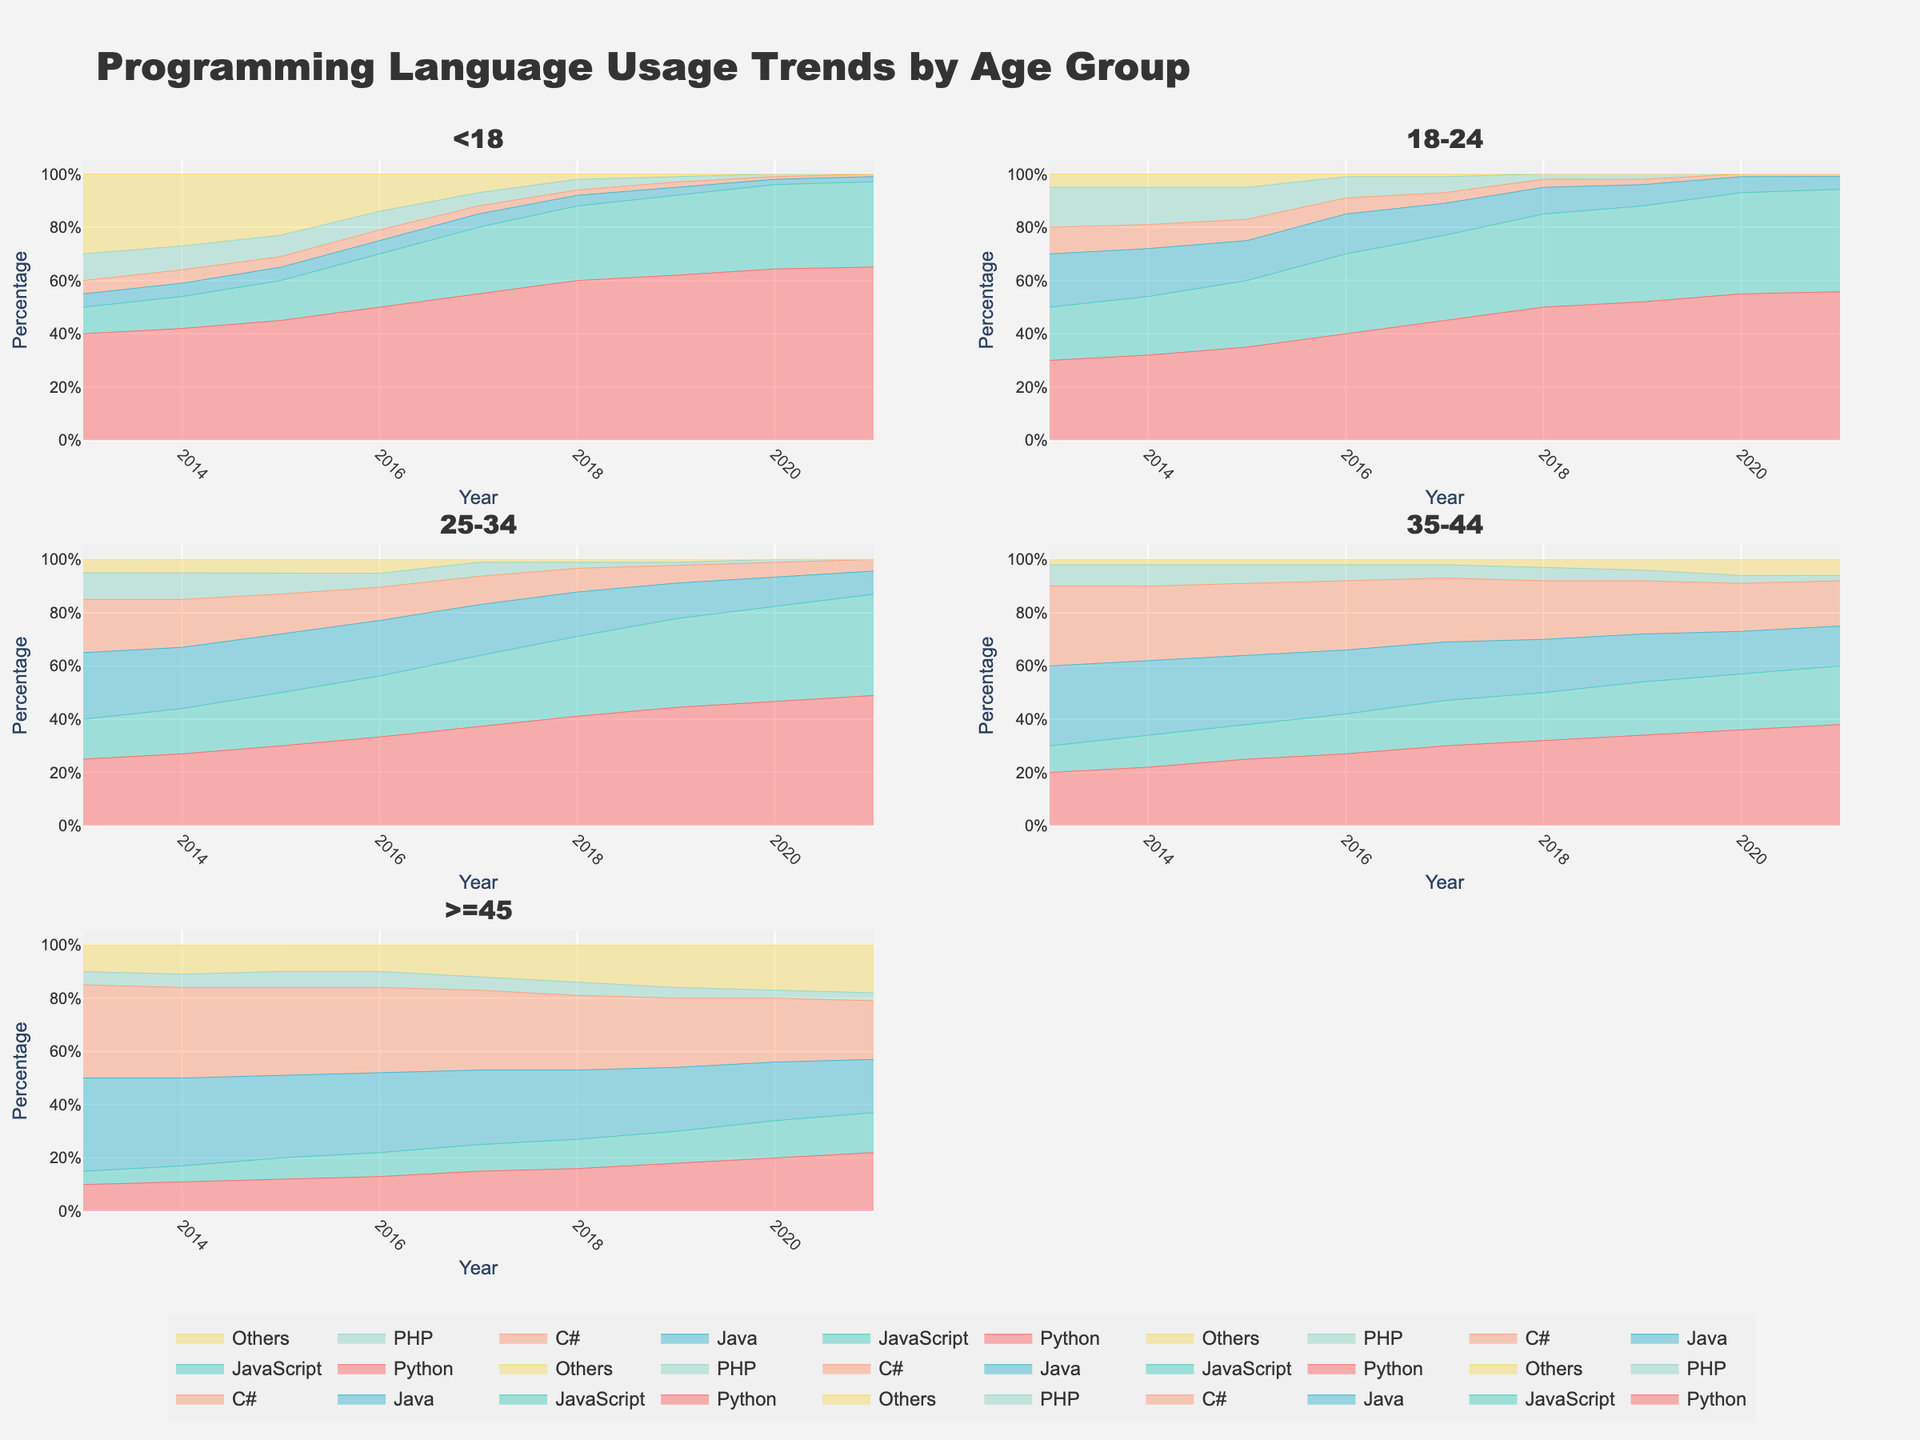What is the title of the figure? The title of the figure is displayed prominently at the top. It helps to understand the main subject of the figure.
Answer: Programming Language Usage Trends by Age Group Which programming language has the highest percentage usage in the age group "<18" in 2016? To find the highest percentage usage in 2016 for the "<18" age group, locate the subplot for "<18". Then, identify the stack area that reaches the highest point in that year. Python is the tallest stack in 2016.
Answer: Python How has the usage trend of JavaScript changed for the "25-34" age group from 2013 to 2021? For this, look at the JavaScript area in the subplot for "25-34". Track the change from the left side (2013) to the right side (2021). JavaScript usage increases consistently over the years.
Answer: Increased Which age group shows the most significant increase in Python usage between 2013 and 2021? By comparing the increase in Python usage across all age groups from 2013 to 2021, we can see which group has the most significant change. In every subplot, observe the growth in the Python area. The "<18" age group shows the most significant increase.
Answer: <18 In 2019, what is the combined usage percentage of C# and PHP for the "35-44" age group? In the "35-44" age group's subplot, find the values for C# and PHP in 2019. Add these percentages together to get the combined usage. C# is 20%, and PHP is 4%. Summing them gives 24%.
Answer: 24% Which programming language's usage declined the most for those aged ">=45" between 2013 and 2021? Examine the ">=45" age group subplot, observing the trends for all languages between 2013 and 2021. Identify the language with the most noticeable decrease. Java's percentage drops significantly over this period.
Answer: Java What is the average percentage usage of Python across all age groups in 2021? To find this, look at the Python usage in all subplots for the year 2021. Sum each percentage and divide by the number of age groups. Summing the percentages: 67 + 58 + 45 + 38 + 22 = 230. Average is 230 / 5 = 46%.
Answer: 46% In the age group "18-24," what is the difference in PHP usage between 2014 and 2018? To determine the difference in PHP usage, locate the values for PHP in 2014 and 2018 within the "18-24" age group subplot. Subtract the 2018 value from the 2014 value. 14% in 2014 minus 2% in 2018 equals a difference of 12%.
Answer: 12% Which age group has the highest percentage of "Others" usage in 2016, and what is that percentage? Analyze the "Others" area for all subplots in the year 2016. Compare the heights and find the highest one. The ">=45" age group shows the highest percentage at 10%.
Answer: >=45, 10% How does the trend of C# usage compare between the "25-34" and "35-44" age groups from 2013 to 2021? Compare the C# area trends in the "25-34" and "35-44" subplots from 2013 to 2021. Note the differences in decline rates. Both show a decreasing trend, but "35-44" has a more consistent decline.
Answer: Both decline, "35-44" more consistently 